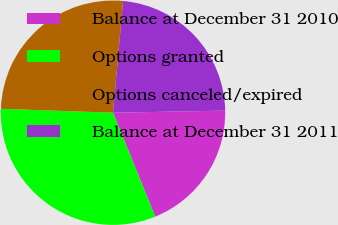Convert chart. <chart><loc_0><loc_0><loc_500><loc_500><pie_chart><fcel>Balance at December 31 2010<fcel>Options granted<fcel>Options canceled/expired<fcel>Balance at December 31 2011<nl><fcel>19.15%<fcel>31.69%<fcel>25.88%<fcel>23.28%<nl></chart> 